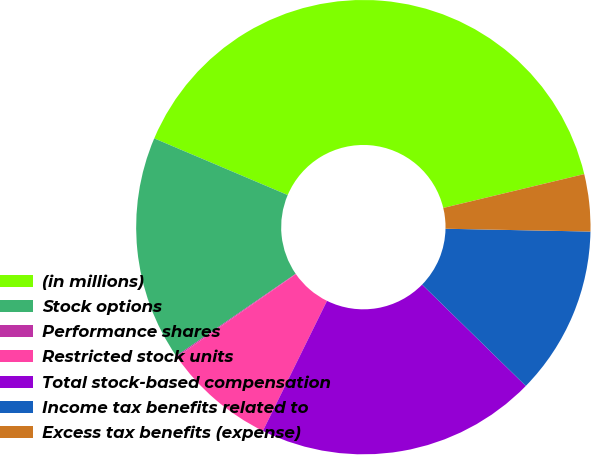Convert chart. <chart><loc_0><loc_0><loc_500><loc_500><pie_chart><fcel>(in millions)<fcel>Stock options<fcel>Performance shares<fcel>Restricted stock units<fcel>Total stock-based compensation<fcel>Income tax benefits related to<fcel>Excess tax benefits (expense)<nl><fcel>39.86%<fcel>15.99%<fcel>0.08%<fcel>8.03%<fcel>19.97%<fcel>12.01%<fcel>4.06%<nl></chart> 